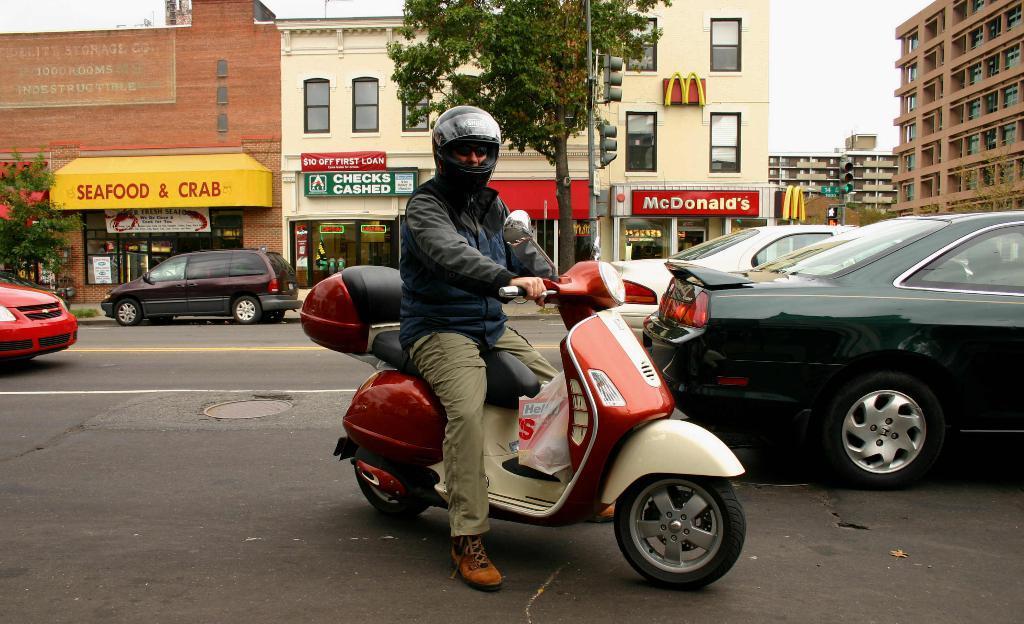In one or two sentences, can you explain what this image depicts? A man is riding a Scooty. On the right there are cars in the middle there is a tree. 